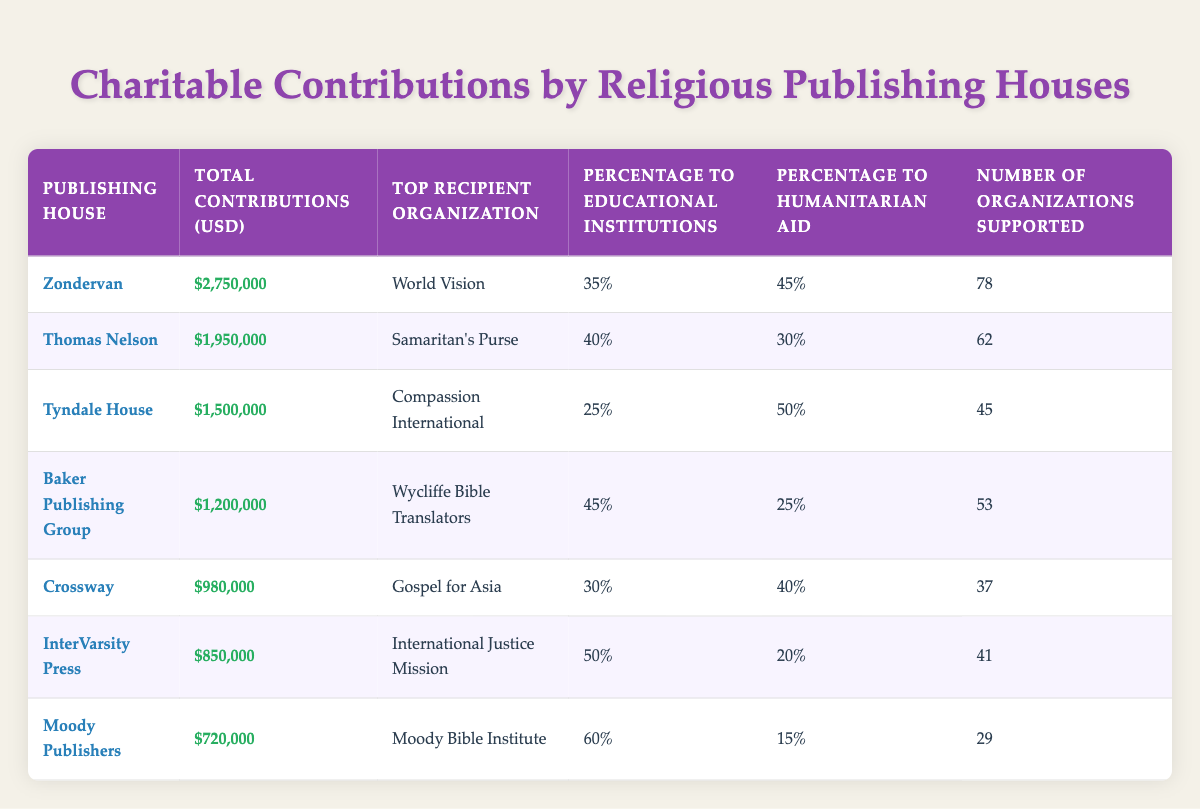What is the total contribution made by Zondervan? The total contributions made by Zondervan, as seen in the table, is listed directly in the "Total Contributions (USD)" column. It shows that Zondervan contributed a total of 2,750,000 USD.
Answer: 2,750,000 USD Which publishing house has supported the most organizations? To find out the publishing house that supported the most organizations, we examine the "Number of Organizations Supported" column. Zondervan supported 78 organizations, which is the highest number compared to others listed.
Answer: Zondervan What percentage of contributions by Tyndale House went to humanitarian aid? The "Percentage to Humanitarian Aid" column for Tyndale House specifies the percentage of contributions directed to humanitarian aid as 50%. This value is directly taken from the table.
Answer: 50% Which publishing house made the least total contributions? We look across the "Total Contributions (USD)" column to find the minimum value. Moody Publishers had the lowest contributions at 720,000 USD, which confirms it as the publishing house with the least total contributions.
Answer: Moody Publishers Is it true that Baker Publishing Group allocated more than 40% of its contributions to educational institutions? Checking the "Percentage to Educational Institutions" for Baker Publishing Group reveals a value of 45%. Since 45% is indeed greater than 40%, the answer to the question is true.
Answer: True What is the average percentage of contributions to educational institutions across all publishing houses? We will calculate the average by summing the percentages to educational institutions from each publishing house, which totals to 35 + 40 + 25 + 45 + 30 + 50 + 60 = 285. There are 7 data points, thus the average percentage is 285 / 7 ≈ 40.71%.
Answer: Approximately 40.71% How many total contributions were made by both Thomas Nelson and Tyndale House combined? To find the total contributions from both publishers, we sum their contributions from the "Total Contributions (USD)" column: 1,950,000 (Thomas Nelson) + 1,500,000 (Tyndale House) = 3,450,000.
Answer: 3,450,000 USD Which organization received the highest contribution, and from which publishing house did it come? Identifying the "Top Recipient Organization" for the largest sum in "Total Contributions (USD)", we find that World Vision received funds from Zondervan, which has the highest contribution of 2,750,000 USD.
Answer: World Vision from Zondervan What is the difference in total contributions between the highest and lowest contributing publishing houses? The highest total contribution is from Zondervan (2,750,000 USD) and the lowest is from Moody Publishers (720,000 USD). The difference is calculated as 2,750,000 - 720,000 = 2,030,000.
Answer: 2,030,000 USD 